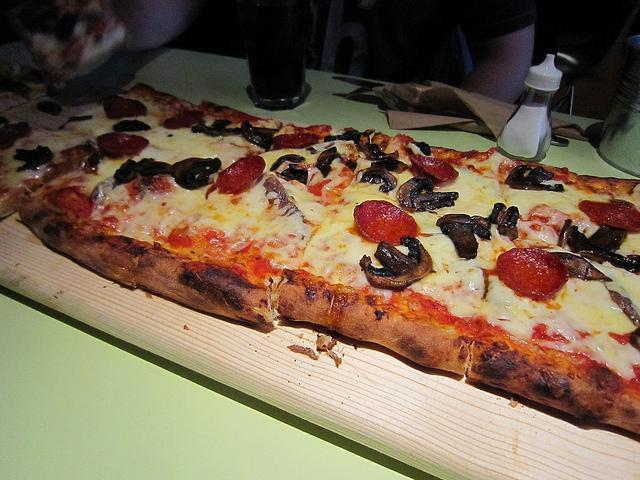Does the description: "The pizza is into the person." accurately reflect the image?
Answer yes or no. No. 